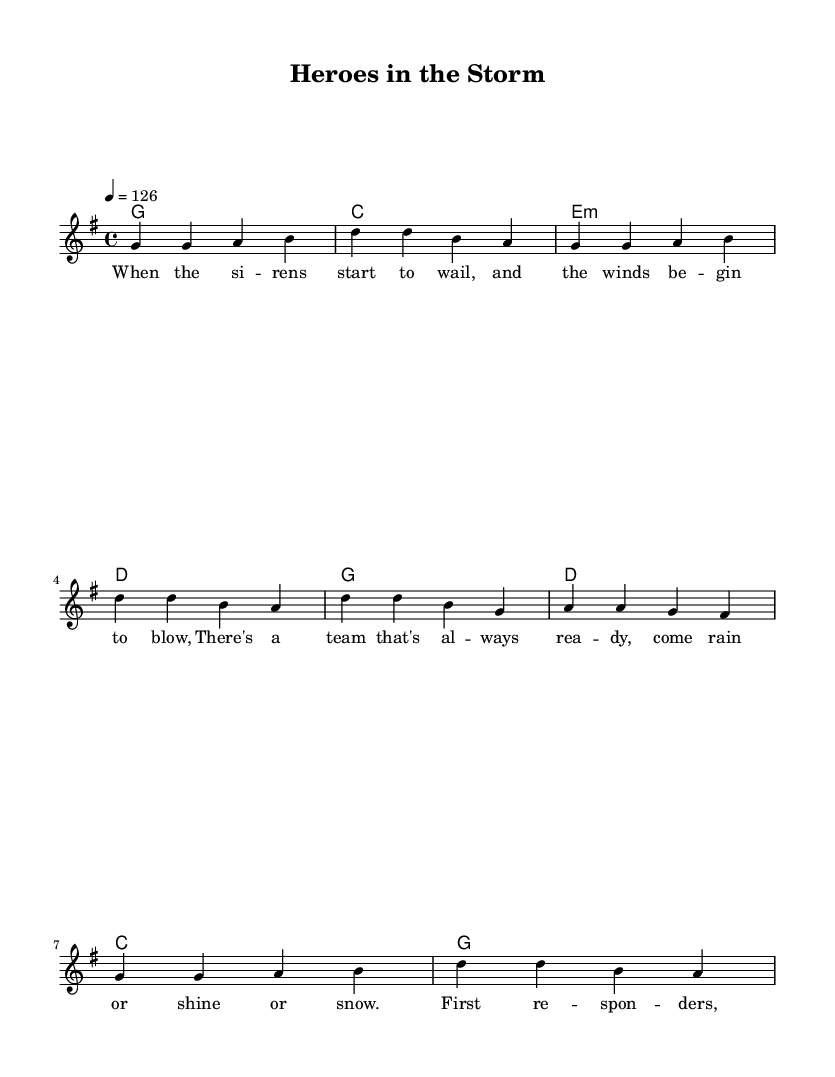What is the key signature of this music? The key signature is G major, which has one sharp (F#). This can be identified at the beginning of the sheet music under the clef symbol.
Answer: G major What is the time signature of this music? The time signature is 4/4, indicated at the beginning of the piece. This means there are four beats in each measure with a quarter note receiving one beat.
Answer: 4/4 What is the tempo of the piece? The tempo marking indicates 126 beats per minute, equivalent to a moderate speed suitable for a lively country rock anthem. This is noted above the staff as "4 = 126".
Answer: 126 How many measures are there in the verse? The verse consists of eight measures, as seen in the structure of the melody, where four measures are listed, repeated once.
Answer: 8 What is the primary theme of the lyrics? The primary theme celebrates the bravery and dedication of first responders and emergency workers in challenging situations. This is reflected in the wording of the lyrics which focus on their readiness and heroism.
Answer: Bravery Which section of the piece is repeated after the verse? The chorus follows the verse, consisting of lines that reinforce the message about first responders, indicating their crucial role in emergencies. This structure is common in country rock music to emphasize themes.
Answer: Chorus 